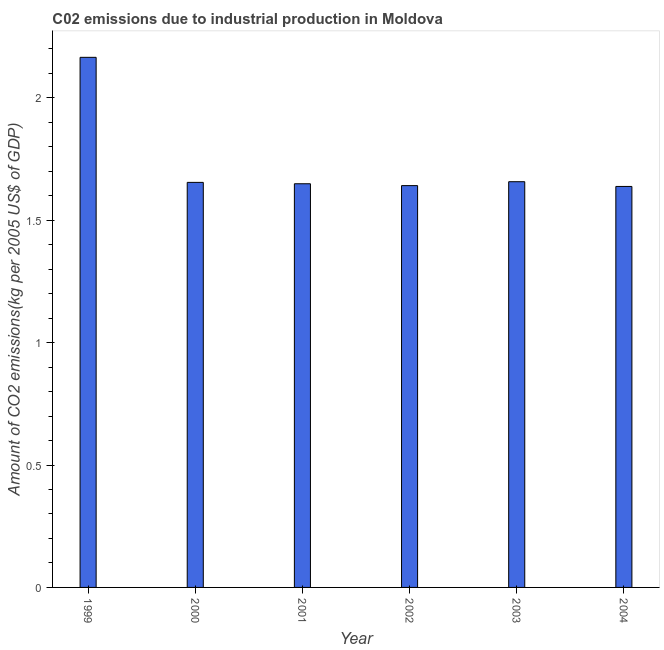What is the title of the graph?
Your answer should be compact. C02 emissions due to industrial production in Moldova. What is the label or title of the Y-axis?
Provide a succinct answer. Amount of CO2 emissions(kg per 2005 US$ of GDP). What is the amount of co2 emissions in 1999?
Make the answer very short. 2.17. Across all years, what is the maximum amount of co2 emissions?
Make the answer very short. 2.17. Across all years, what is the minimum amount of co2 emissions?
Make the answer very short. 1.64. In which year was the amount of co2 emissions minimum?
Provide a succinct answer. 2004. What is the sum of the amount of co2 emissions?
Your answer should be very brief. 10.41. What is the difference between the amount of co2 emissions in 2003 and 2004?
Keep it short and to the point. 0.02. What is the average amount of co2 emissions per year?
Your answer should be compact. 1.73. What is the median amount of co2 emissions?
Offer a very short reply. 1.65. What is the ratio of the amount of co2 emissions in 2000 to that in 2001?
Your answer should be very brief. 1. What is the difference between the highest and the second highest amount of co2 emissions?
Offer a very short reply. 0.51. Is the sum of the amount of co2 emissions in 2001 and 2004 greater than the maximum amount of co2 emissions across all years?
Provide a succinct answer. Yes. What is the difference between the highest and the lowest amount of co2 emissions?
Your response must be concise. 0.53. Are all the bars in the graph horizontal?
Offer a very short reply. No. What is the Amount of CO2 emissions(kg per 2005 US$ of GDP) of 1999?
Your answer should be compact. 2.17. What is the Amount of CO2 emissions(kg per 2005 US$ of GDP) in 2000?
Your answer should be compact. 1.65. What is the Amount of CO2 emissions(kg per 2005 US$ of GDP) in 2001?
Your answer should be very brief. 1.65. What is the Amount of CO2 emissions(kg per 2005 US$ of GDP) in 2002?
Provide a short and direct response. 1.64. What is the Amount of CO2 emissions(kg per 2005 US$ of GDP) of 2003?
Your response must be concise. 1.66. What is the Amount of CO2 emissions(kg per 2005 US$ of GDP) in 2004?
Your answer should be very brief. 1.64. What is the difference between the Amount of CO2 emissions(kg per 2005 US$ of GDP) in 1999 and 2000?
Keep it short and to the point. 0.51. What is the difference between the Amount of CO2 emissions(kg per 2005 US$ of GDP) in 1999 and 2001?
Offer a very short reply. 0.52. What is the difference between the Amount of CO2 emissions(kg per 2005 US$ of GDP) in 1999 and 2002?
Offer a very short reply. 0.52. What is the difference between the Amount of CO2 emissions(kg per 2005 US$ of GDP) in 1999 and 2003?
Keep it short and to the point. 0.51. What is the difference between the Amount of CO2 emissions(kg per 2005 US$ of GDP) in 1999 and 2004?
Provide a succinct answer. 0.53. What is the difference between the Amount of CO2 emissions(kg per 2005 US$ of GDP) in 2000 and 2001?
Ensure brevity in your answer.  0.01. What is the difference between the Amount of CO2 emissions(kg per 2005 US$ of GDP) in 2000 and 2002?
Offer a terse response. 0.01. What is the difference between the Amount of CO2 emissions(kg per 2005 US$ of GDP) in 2000 and 2003?
Make the answer very short. -0. What is the difference between the Amount of CO2 emissions(kg per 2005 US$ of GDP) in 2000 and 2004?
Your response must be concise. 0.02. What is the difference between the Amount of CO2 emissions(kg per 2005 US$ of GDP) in 2001 and 2002?
Offer a terse response. 0.01. What is the difference between the Amount of CO2 emissions(kg per 2005 US$ of GDP) in 2001 and 2003?
Offer a very short reply. -0.01. What is the difference between the Amount of CO2 emissions(kg per 2005 US$ of GDP) in 2001 and 2004?
Your response must be concise. 0.01. What is the difference between the Amount of CO2 emissions(kg per 2005 US$ of GDP) in 2002 and 2003?
Ensure brevity in your answer.  -0.02. What is the difference between the Amount of CO2 emissions(kg per 2005 US$ of GDP) in 2002 and 2004?
Ensure brevity in your answer.  0. What is the difference between the Amount of CO2 emissions(kg per 2005 US$ of GDP) in 2003 and 2004?
Offer a terse response. 0.02. What is the ratio of the Amount of CO2 emissions(kg per 2005 US$ of GDP) in 1999 to that in 2000?
Your answer should be compact. 1.31. What is the ratio of the Amount of CO2 emissions(kg per 2005 US$ of GDP) in 1999 to that in 2001?
Keep it short and to the point. 1.31. What is the ratio of the Amount of CO2 emissions(kg per 2005 US$ of GDP) in 1999 to that in 2002?
Offer a terse response. 1.32. What is the ratio of the Amount of CO2 emissions(kg per 2005 US$ of GDP) in 1999 to that in 2003?
Ensure brevity in your answer.  1.31. What is the ratio of the Amount of CO2 emissions(kg per 2005 US$ of GDP) in 1999 to that in 2004?
Offer a terse response. 1.32. What is the ratio of the Amount of CO2 emissions(kg per 2005 US$ of GDP) in 2000 to that in 2001?
Offer a very short reply. 1. What is the ratio of the Amount of CO2 emissions(kg per 2005 US$ of GDP) in 2000 to that in 2003?
Make the answer very short. 1. What is the ratio of the Amount of CO2 emissions(kg per 2005 US$ of GDP) in 2000 to that in 2004?
Provide a succinct answer. 1.01. What is the ratio of the Amount of CO2 emissions(kg per 2005 US$ of GDP) in 2001 to that in 2004?
Provide a succinct answer. 1.01. What is the ratio of the Amount of CO2 emissions(kg per 2005 US$ of GDP) in 2002 to that in 2003?
Your answer should be compact. 0.99. 